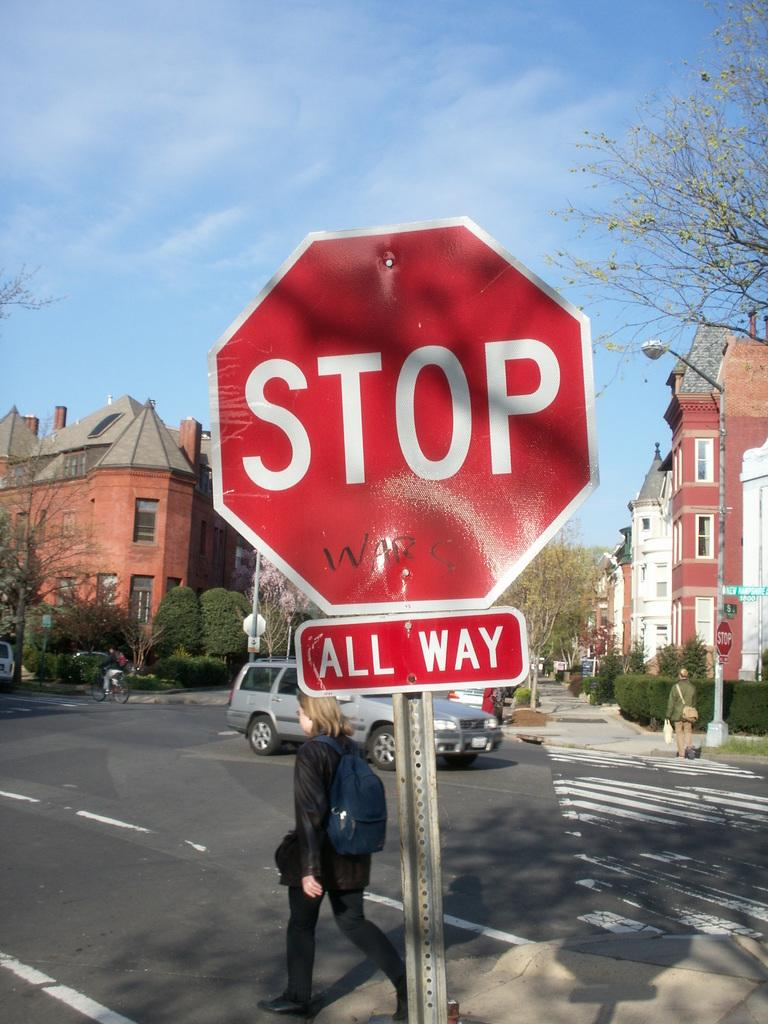<image>
Relay a brief, clear account of the picture shown. All Way Stop Sign with writing on it that says War, 